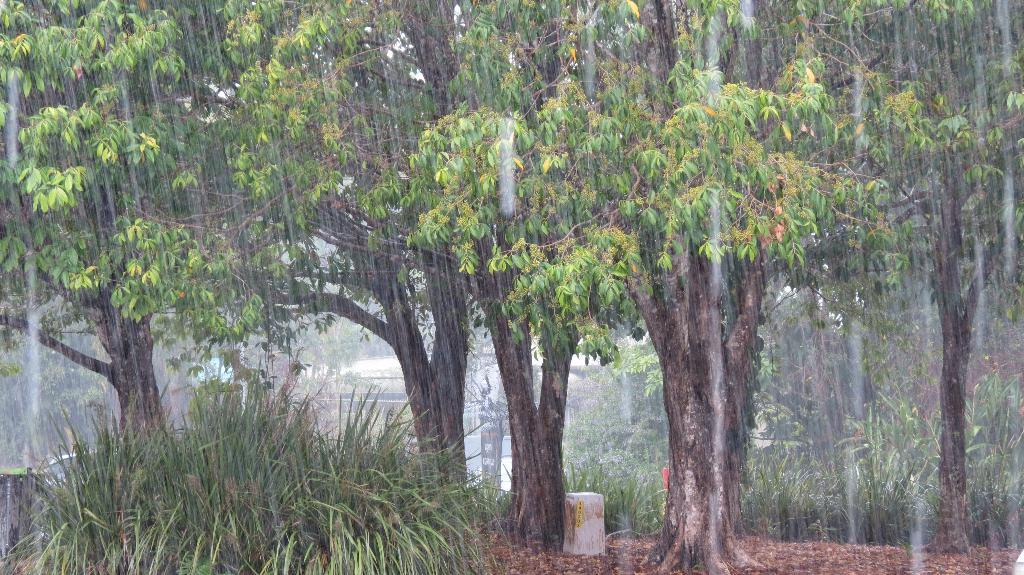Where was the picture taken? The picture was clicked outside. What can be seen in the foreground of the image? There is grass in the foreground of the image. What is visible in the background of the image? The sky is visible in the background of the image. What is the weather like in the scene? It is raining in the scene. What color is the grass in the image? There is green grass in the image. What other items can be seen in the image besides the grass and sky? There are other items visible in the image. Can you see any houses being attacked by an elbow in the image? No, there are no houses or elbows present in the image. 